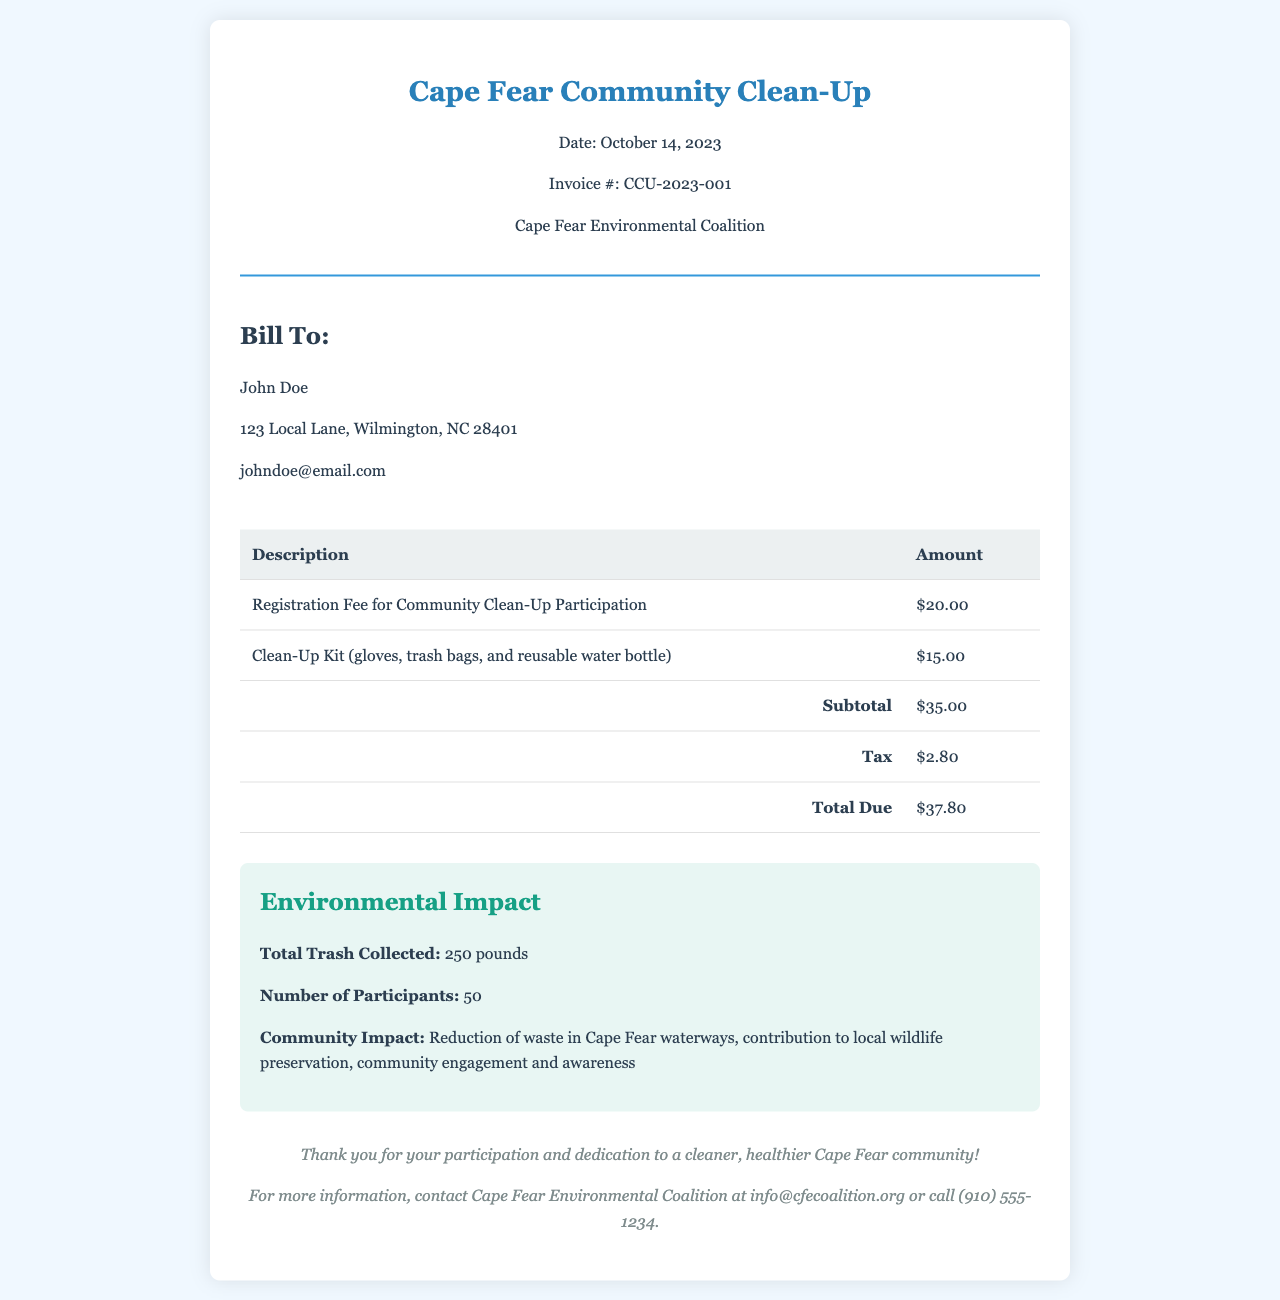What is the invoice number? The invoice number is listed prominently in the document, which is helpful for tracking and reference.
Answer: CCU-2023-001 Who is billed in this invoice? The bill-to section provides the name of the person being billed, which is important for identifying the recipient.
Answer: John Doe What is the total due amount? The total amount due is clearly stated at the bottom of the invoice, summarizing the costs related to this event.
Answer: $37.80 What was the registration fee for participation? The registration fee is specified in the line items of the invoice, indicating the cost associated with participating in the event.
Answer: $20.00 How many pounds of trash were collected? The environmental impact section provides key metrics about the event's success, including the amount of trash collected.
Answer: 250 pounds What items were included in the clean-up kit? The clean-up kit details are mentioned in the invoice, outlining the materials provided to participants, which shows the effort to facilitate participation.
Answer: gloves, trash bags, and reusable water bottle What is the date of the community clean-up event? The date of the event is stated in the header, which is crucial for understanding when the participation took place.
Answer: October 14, 2023 How many participants were involved in the clean-up? The number of participants helps gauge the level of community involvement and is part of the impact assessment.
Answer: 50 What is the community impact achieved from the clean-up? The document summarizes the broader implications of the clean-up, highlighting the benefits to both the environment and community engagement.
Answer: Reduction of waste in Cape Fear waterways, contribution to local wildlife preservation, community engagement and awareness 